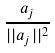Convert formula to latex. <formula><loc_0><loc_0><loc_500><loc_500>\frac { a _ { j } } { | | a _ { j } | | ^ { 2 } }</formula> 